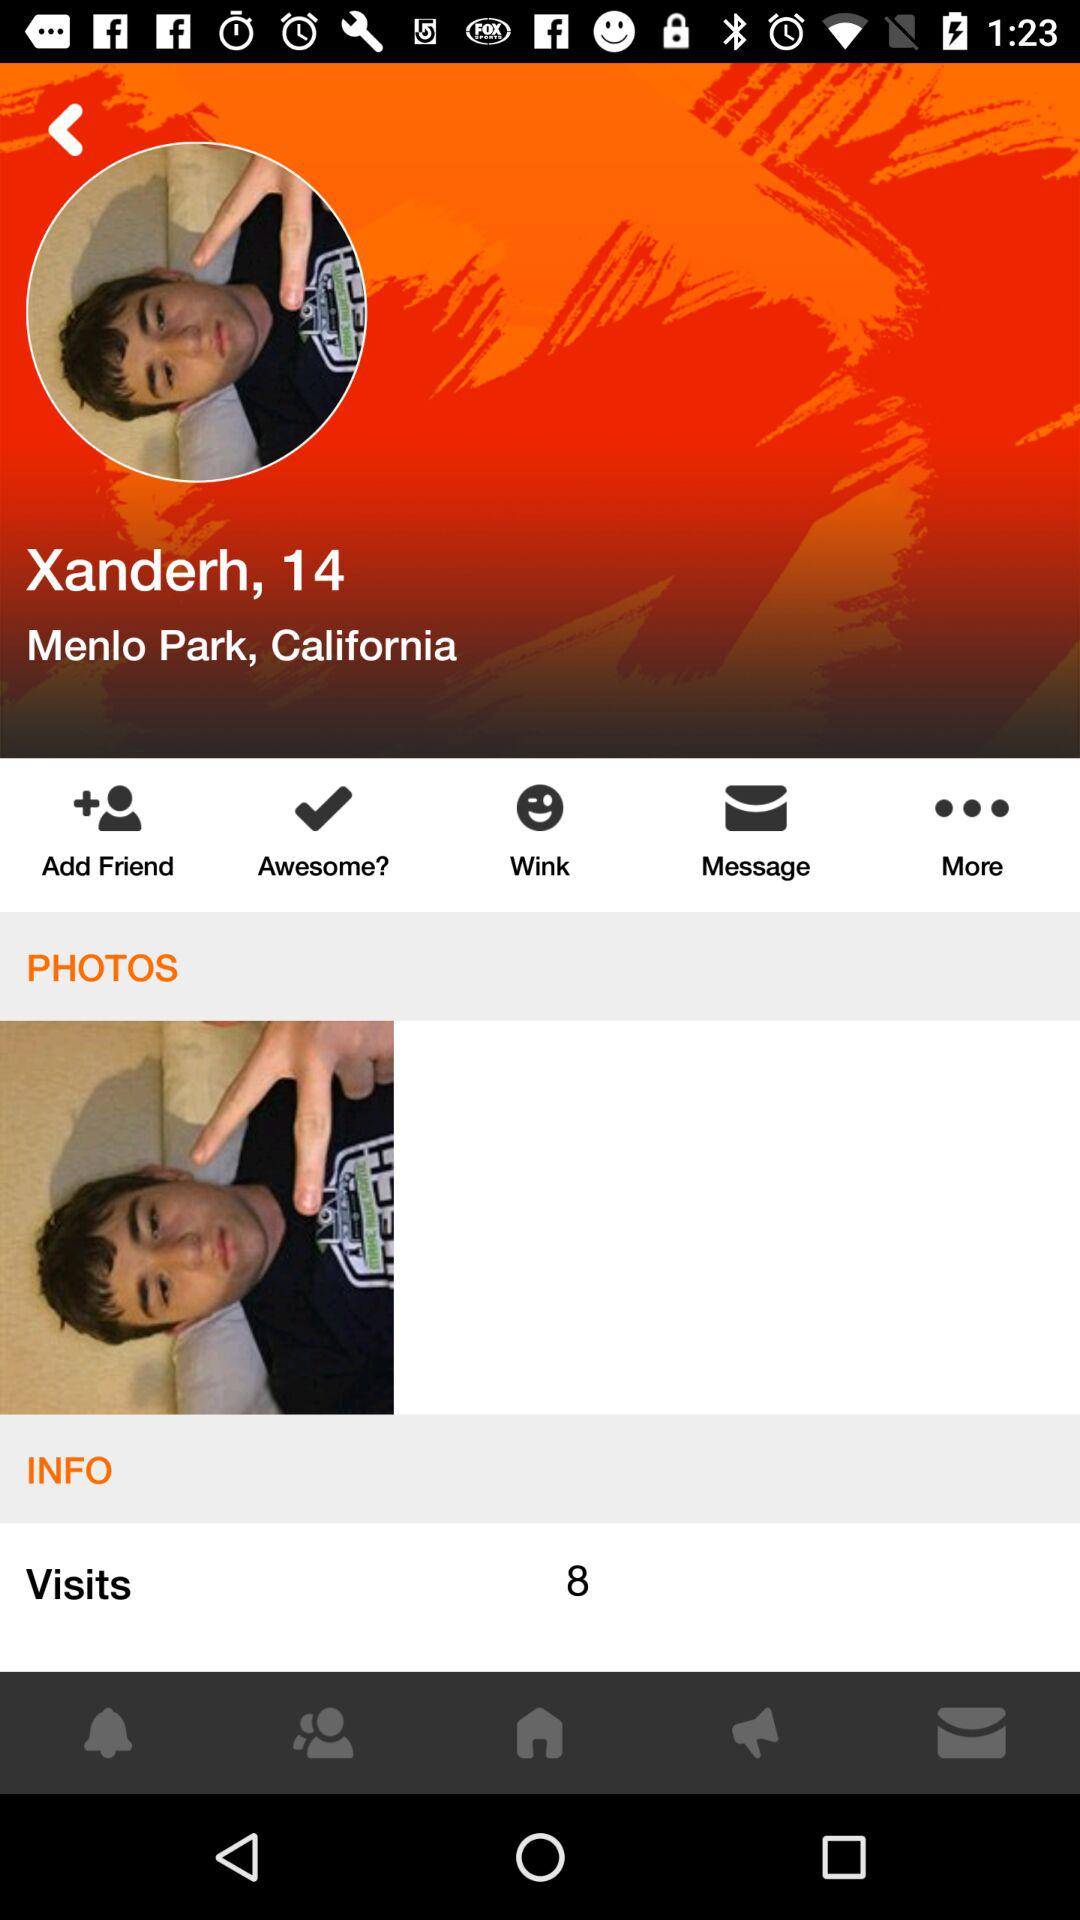Where is Xanderh from? Xanderh is from Menlo Park, California. 